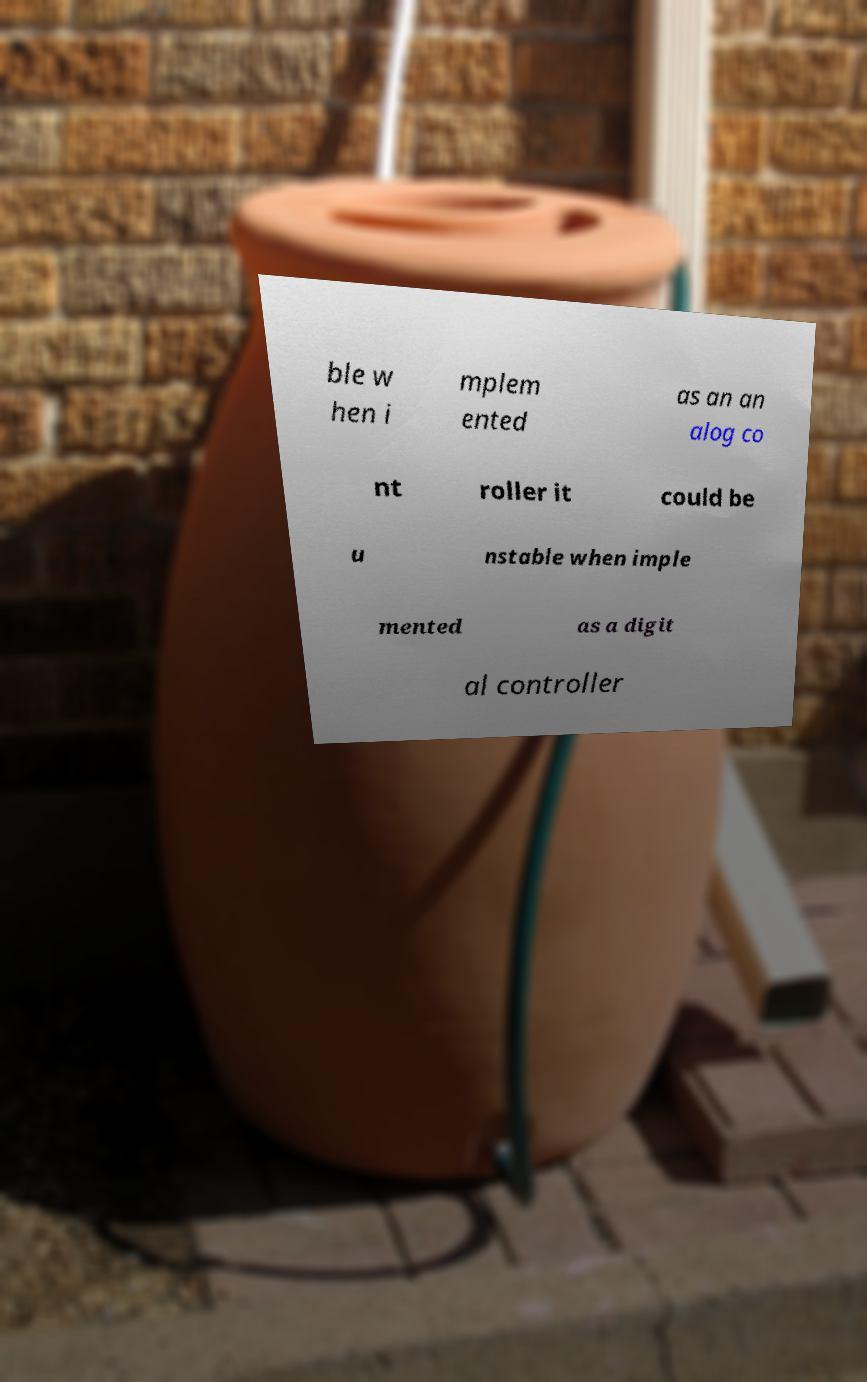There's text embedded in this image that I need extracted. Can you transcribe it verbatim? ble w hen i mplem ented as an an alog co nt roller it could be u nstable when imple mented as a digit al controller 